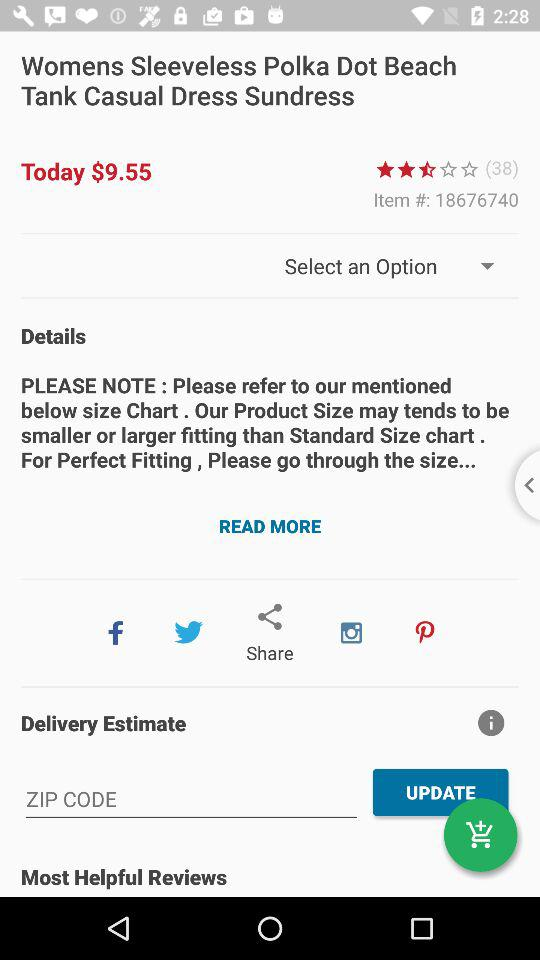How many reviews does the product have?
Answer the question using a single word or phrase. 38 